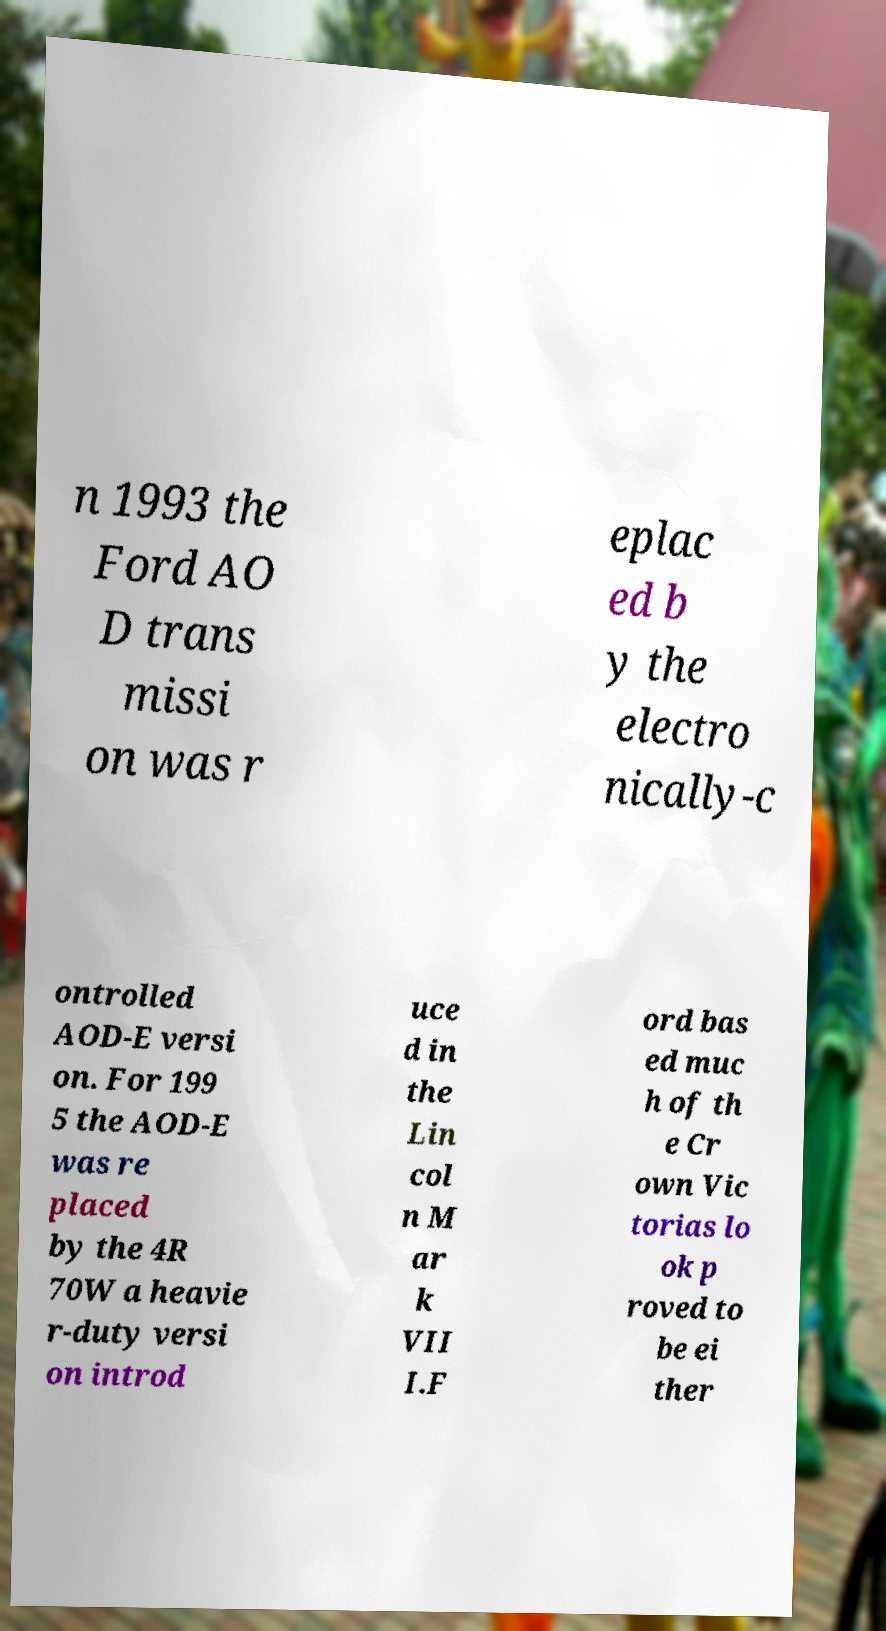There's text embedded in this image that I need extracted. Can you transcribe it verbatim? n 1993 the Ford AO D trans missi on was r eplac ed b y the electro nically-c ontrolled AOD-E versi on. For 199 5 the AOD-E was re placed by the 4R 70W a heavie r-duty versi on introd uce d in the Lin col n M ar k VII I.F ord bas ed muc h of th e Cr own Vic torias lo ok p roved to be ei ther 